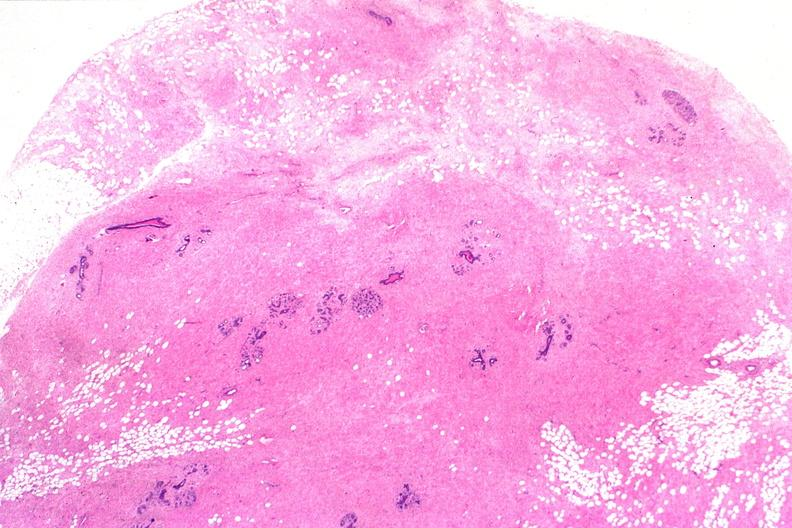s female reproductive present?
Answer the question using a single word or phrase. Yes 